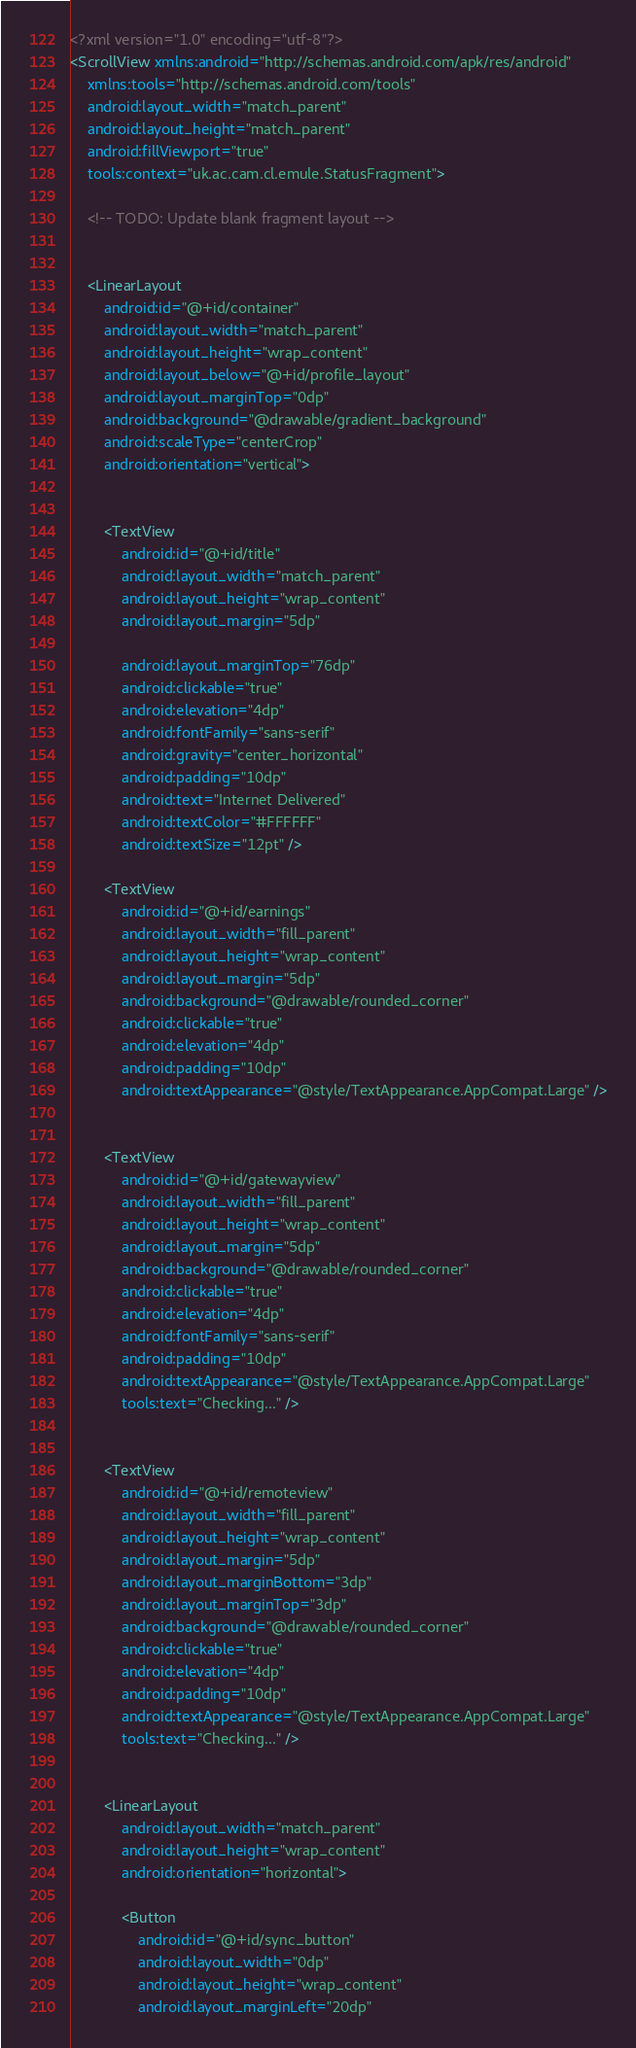Convert code to text. <code><loc_0><loc_0><loc_500><loc_500><_XML_><?xml version="1.0" encoding="utf-8"?>
<ScrollView xmlns:android="http://schemas.android.com/apk/res/android"
    xmlns:tools="http://schemas.android.com/tools"
    android:layout_width="match_parent"
    android:layout_height="match_parent"
    android:fillViewport="true"
    tools:context="uk.ac.cam.cl.emule.StatusFragment">

    <!-- TODO: Update blank fragment layout -->


    <LinearLayout
        android:id="@+id/container"
        android:layout_width="match_parent"
        android:layout_height="wrap_content"
        android:layout_below="@+id/profile_layout"
        android:layout_marginTop="0dp"
        android:background="@drawable/gradient_background"
        android:scaleType="centerCrop"
        android:orientation="vertical">


        <TextView
            android:id="@+id/title"
            android:layout_width="match_parent"
            android:layout_height="wrap_content"
            android:layout_margin="5dp"

            android:layout_marginTop="76dp"
            android:clickable="true"
            android:elevation="4dp"
            android:fontFamily="sans-serif"
            android:gravity="center_horizontal"
            android:padding="10dp"
            android:text="Internet Delivered"
            android:textColor="#FFFFFF"
            android:textSize="12pt" />

        <TextView
            android:id="@+id/earnings"
            android:layout_width="fill_parent"
            android:layout_height="wrap_content"
            android:layout_margin="5dp"
            android:background="@drawable/rounded_corner"
            android:clickable="true"
            android:elevation="4dp"
            android:padding="10dp"
            android:textAppearance="@style/TextAppearance.AppCompat.Large" />


        <TextView
            android:id="@+id/gatewayview"
            android:layout_width="fill_parent"
            android:layout_height="wrap_content"
            android:layout_margin="5dp"
            android:background="@drawable/rounded_corner"
            android:clickable="true"
            android:elevation="4dp"
            android:fontFamily="sans-serif"
            android:padding="10dp"
            android:textAppearance="@style/TextAppearance.AppCompat.Large"
            tools:text="Checking..." />


        <TextView
            android:id="@+id/remoteview"
            android:layout_width="fill_parent"
            android:layout_height="wrap_content"
            android:layout_margin="5dp"
            android:layout_marginBottom="3dp"
            android:layout_marginTop="3dp"
            android:background="@drawable/rounded_corner"
            android:clickable="true"
            android:elevation="4dp"
            android:padding="10dp"
            android:textAppearance="@style/TextAppearance.AppCompat.Large"
            tools:text="Checking..." />


        <LinearLayout
            android:layout_width="match_parent"
            android:layout_height="wrap_content"
            android:orientation="horizontal">

            <Button
                android:id="@+id/sync_button"
                android:layout_width="0dp"
                android:layout_height="wrap_content"
                android:layout_marginLeft="20dp"</code> 